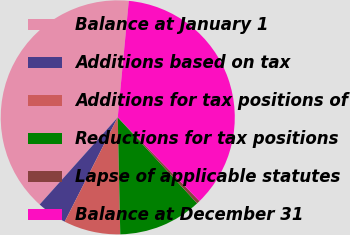Convert chart. <chart><loc_0><loc_0><loc_500><loc_500><pie_chart><fcel>Balance at January 1<fcel>Additions based on tax<fcel>Additions for tax positions of<fcel>Reductions for tax positions<fcel>Lapse of applicable statutes<fcel>Balance at December 31<nl><fcel>39.88%<fcel>4.14%<fcel>7.83%<fcel>11.52%<fcel>0.45%<fcel>36.18%<nl></chart> 